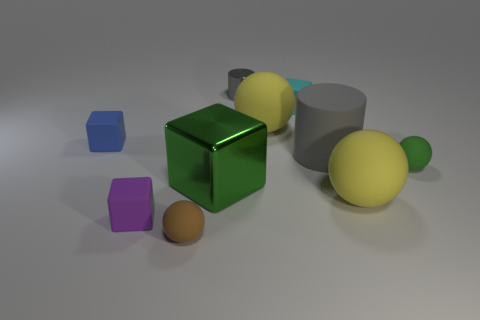What is the shape of the tiny thing that is both behind the blue thing and in front of the small gray cylinder?
Provide a succinct answer. Cube. There is a gray object that is on the left side of the small cyan rubber block; what size is it?
Offer a terse response. Small. Does the matte cylinder have the same size as the green matte thing?
Your response must be concise. No. Is the number of yellow matte objects behind the small gray metallic cylinder less than the number of large yellow rubber spheres on the right side of the cyan block?
Offer a very short reply. Yes. There is a block that is both behind the gray rubber cylinder and on the right side of the tiny brown rubber object; what size is it?
Your response must be concise. Small. There is a yellow ball in front of the yellow matte object that is behind the green matte ball; is there a small gray metal cylinder right of it?
Give a very brief answer. No. Are there any brown cylinders?
Offer a very short reply. No. Are there more tiny spheres that are to the right of the tiny cylinder than brown balls left of the small purple object?
Make the answer very short. Yes. What is the size of the brown ball that is the same material as the cyan object?
Offer a very short reply. Small. What size is the cylinder on the left side of the rubber cube right of the green object that is to the left of the tiny gray cylinder?
Offer a very short reply. Small. 